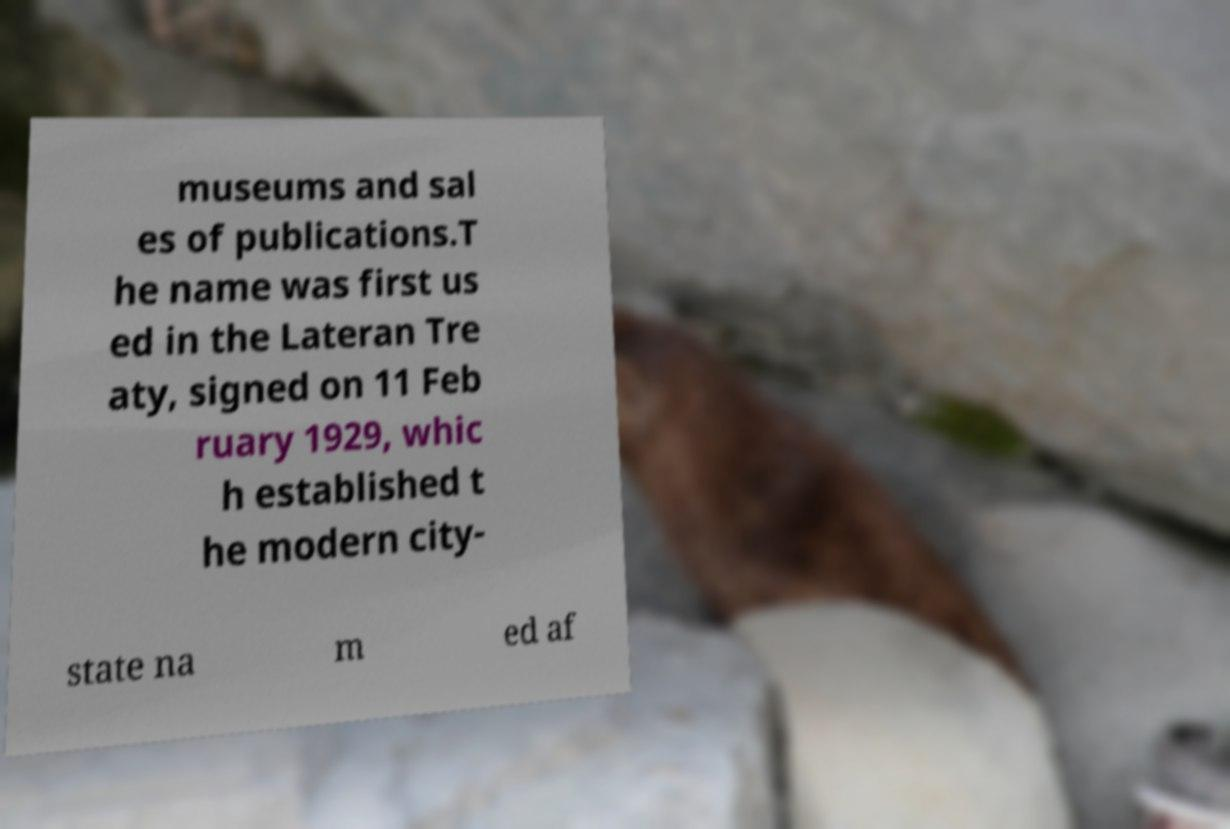For documentation purposes, I need the text within this image transcribed. Could you provide that? museums and sal es of publications.T he name was first us ed in the Lateran Tre aty, signed on 11 Feb ruary 1929, whic h established t he modern city- state na m ed af 